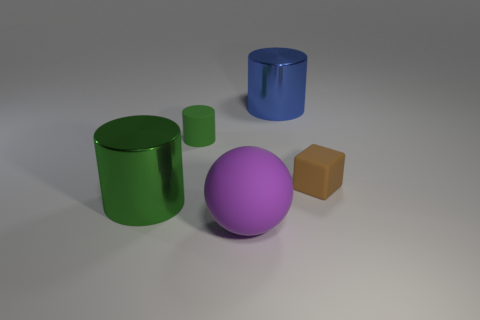Is there any other thing that has the same size as the purple object?
Offer a very short reply. Yes. How big is the blue thing?
Keep it short and to the point. Large. Are there fewer rubber balls that are right of the rubber cube than small green rubber cylinders?
Your response must be concise. Yes. How many cylinders have the same size as the rubber cube?
Your answer should be very brief. 1. The large thing that is the same color as the tiny rubber cylinder is what shape?
Provide a succinct answer. Cylinder. Does the big shiny cylinder that is in front of the tiny cylinder have the same color as the tiny thing behind the matte block?
Offer a very short reply. Yes. There is a large blue shiny thing; how many tiny matte cubes are in front of it?
Offer a terse response. 1. There is a shiny cylinder that is the same color as the small matte cylinder; what is its size?
Provide a succinct answer. Large. Are there any other green things that have the same shape as the small green object?
Your answer should be compact. Yes. There is a rubber cylinder that is the same size as the brown rubber cube; what is its color?
Provide a short and direct response. Green. 